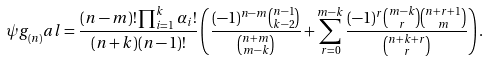Convert formula to latex. <formula><loc_0><loc_0><loc_500><loc_500>\psi g _ { ( n ) } ^ { \ } a l = \frac { ( n - m ) ! \prod _ { i = 1 } ^ { k } \alpha _ { i } ! } { ( n + k ) ( n - 1 ) ! } \left ( \frac { ( - 1 ) ^ { n - m } \binom { n - 1 } { k - 2 } } { \binom { n + m } { m - k } } + \sum _ { r = 0 } ^ { m - k } \frac { ( - 1 ) ^ { r } \binom { m - k } { r } \binom { n + r + 1 } { m } } { \binom { n + k + r } { r } } \right ) .</formula> 